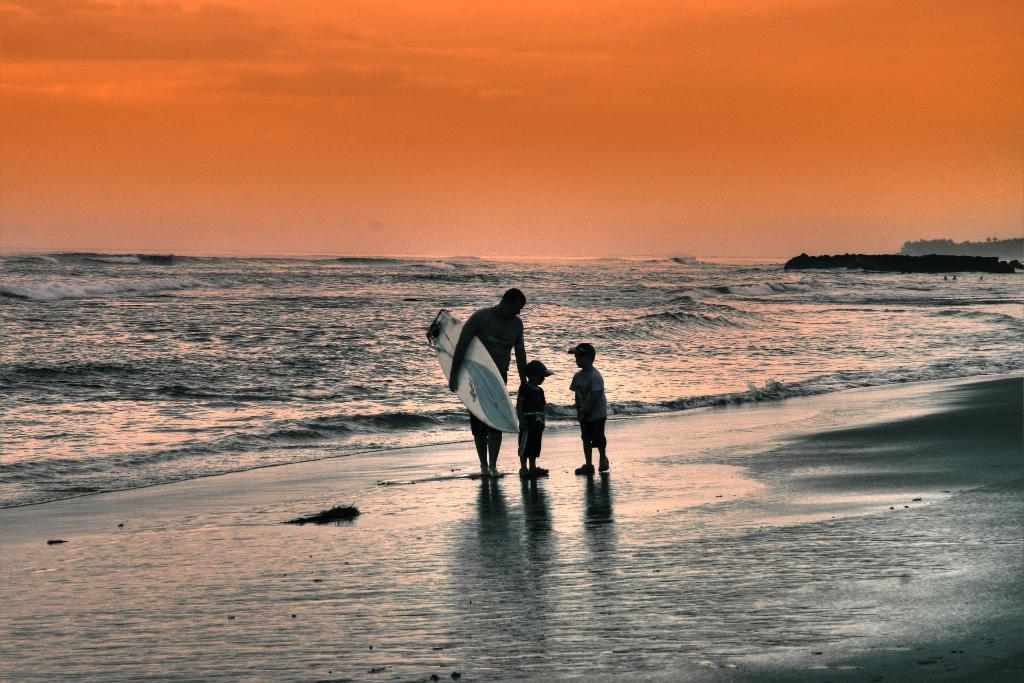How would you summarize this image in a sentence or two? In this image, few peoples are standing near the sea. A man is surfboard on his hand. We can see background the sky. 